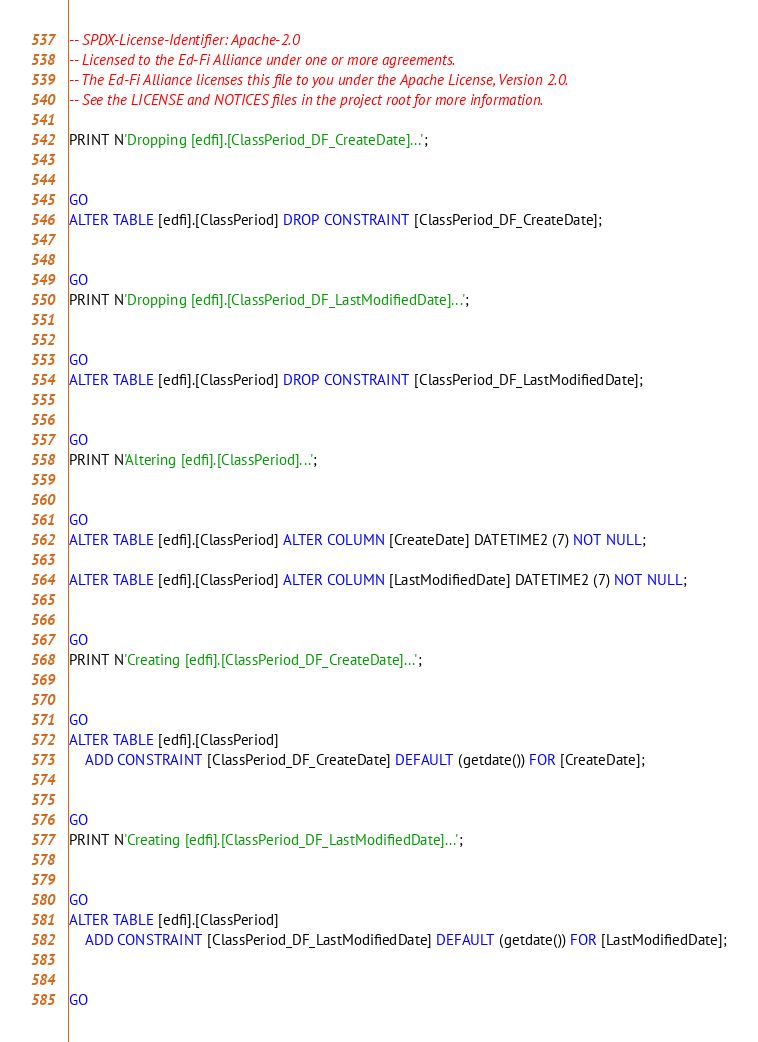<code> <loc_0><loc_0><loc_500><loc_500><_SQL_>-- SPDX-License-Identifier: Apache-2.0
-- Licensed to the Ed-Fi Alliance under one or more agreements.
-- The Ed-Fi Alliance licenses this file to you under the Apache License, Version 2.0.
-- See the LICENSE and NOTICES files in the project root for more information.

PRINT N'Dropping [edfi].[ClassPeriod_DF_CreateDate]...';


GO
ALTER TABLE [edfi].[ClassPeriod] DROP CONSTRAINT [ClassPeriod_DF_CreateDate];


GO
PRINT N'Dropping [edfi].[ClassPeriod_DF_LastModifiedDate]...';


GO
ALTER TABLE [edfi].[ClassPeriod] DROP CONSTRAINT [ClassPeriod_DF_LastModifiedDate];


GO
PRINT N'Altering [edfi].[ClassPeriod]...';


GO
ALTER TABLE [edfi].[ClassPeriod] ALTER COLUMN [CreateDate] DATETIME2 (7) NOT NULL;

ALTER TABLE [edfi].[ClassPeriod] ALTER COLUMN [LastModifiedDate] DATETIME2 (7) NOT NULL;


GO
PRINT N'Creating [edfi].[ClassPeriod_DF_CreateDate]...';


GO
ALTER TABLE [edfi].[ClassPeriod]
    ADD CONSTRAINT [ClassPeriod_DF_CreateDate] DEFAULT (getdate()) FOR [CreateDate];


GO
PRINT N'Creating [edfi].[ClassPeriod_DF_LastModifiedDate]...';


GO
ALTER TABLE [edfi].[ClassPeriod]
    ADD CONSTRAINT [ClassPeriod_DF_LastModifiedDate] DEFAULT (getdate()) FOR [LastModifiedDate];


GO
</code> 